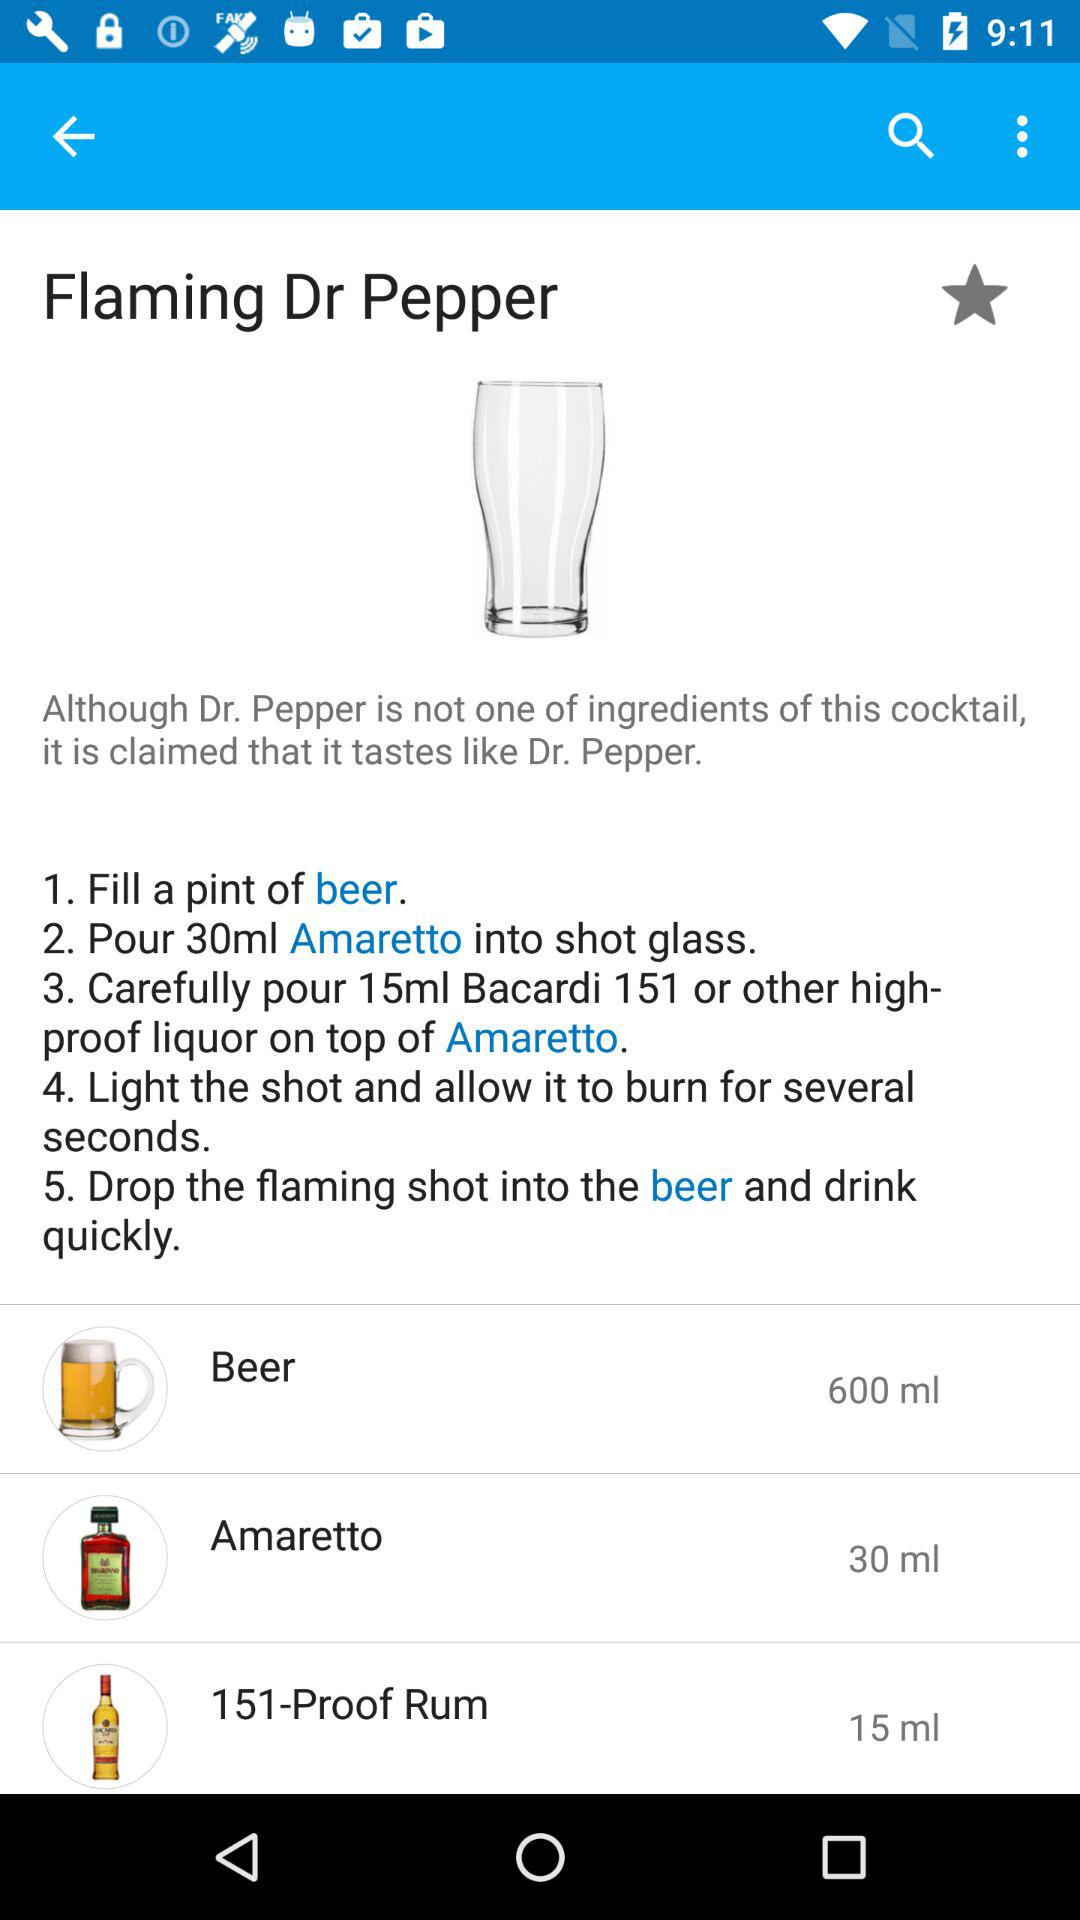How many milliliters of 151-Proof Rum are needed to make this drink?
Answer the question using a single word or phrase. 15 ml 